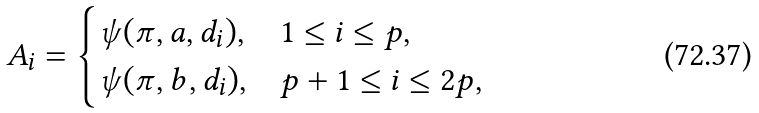<formula> <loc_0><loc_0><loc_500><loc_500>A _ { i } = \begin{cases} \psi ( \pi , a , d _ { i } ) , & 1 \leq i \leq p , \\ \psi ( \pi , b , d _ { i } ) , & p + 1 \leq i \leq 2 p , \end{cases}</formula> 